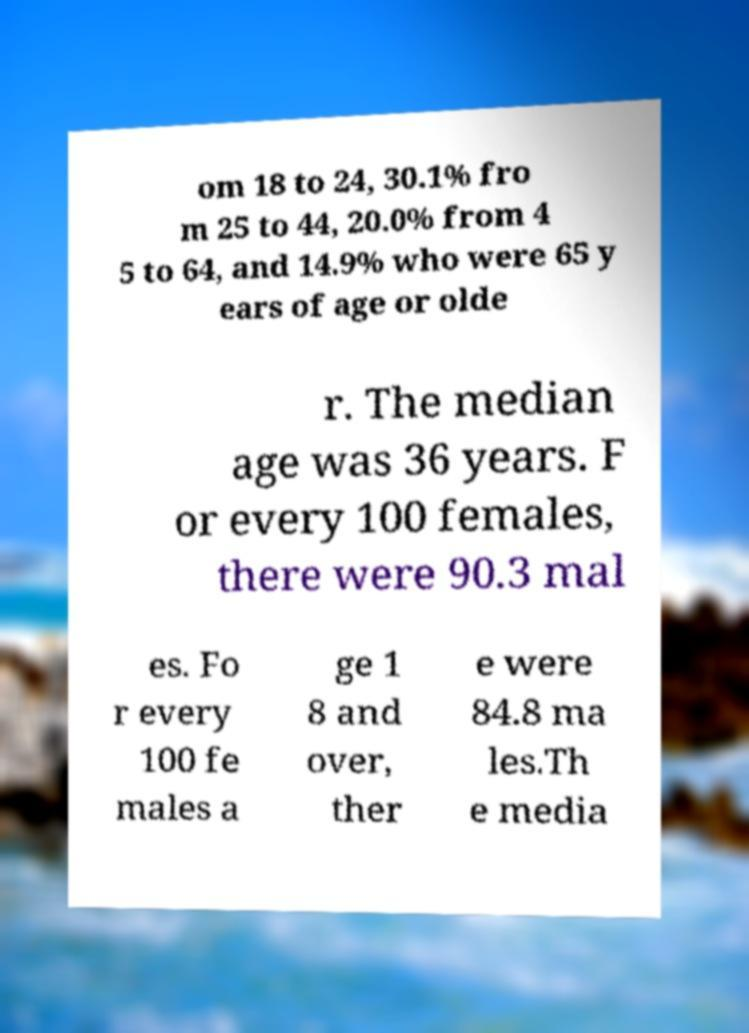There's text embedded in this image that I need extracted. Can you transcribe it verbatim? om 18 to 24, 30.1% fro m 25 to 44, 20.0% from 4 5 to 64, and 14.9% who were 65 y ears of age or olde r. The median age was 36 years. F or every 100 females, there were 90.3 mal es. Fo r every 100 fe males a ge 1 8 and over, ther e were 84.8 ma les.Th e media 